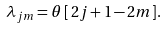<formula> <loc_0><loc_0><loc_500><loc_500>\lambda _ { j m } = \theta \, [ \, 2 j + 1 - 2 m ] .</formula> 